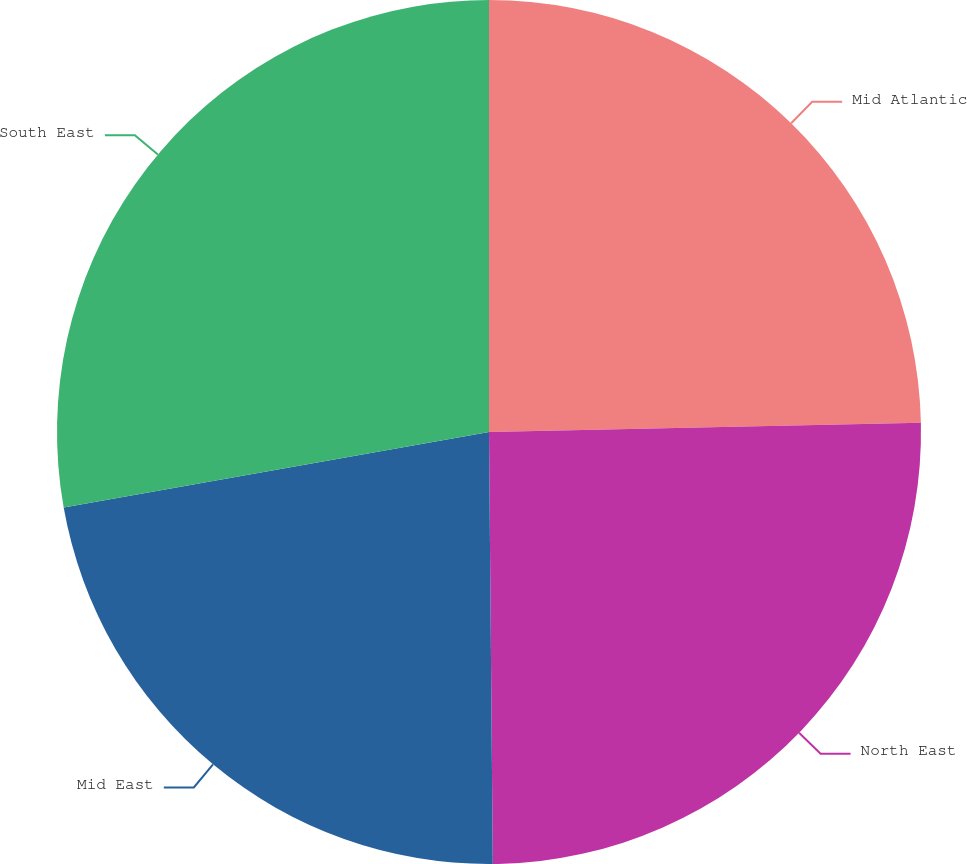<chart> <loc_0><loc_0><loc_500><loc_500><pie_chart><fcel>Mid Atlantic<fcel>North East<fcel>Mid East<fcel>South East<nl><fcel>24.66%<fcel>25.2%<fcel>22.34%<fcel>27.8%<nl></chart> 